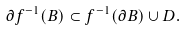<formula> <loc_0><loc_0><loc_500><loc_500>\partial f ^ { - 1 } ( B ) \subset f ^ { - 1 } ( \partial B ) \cup D .</formula> 